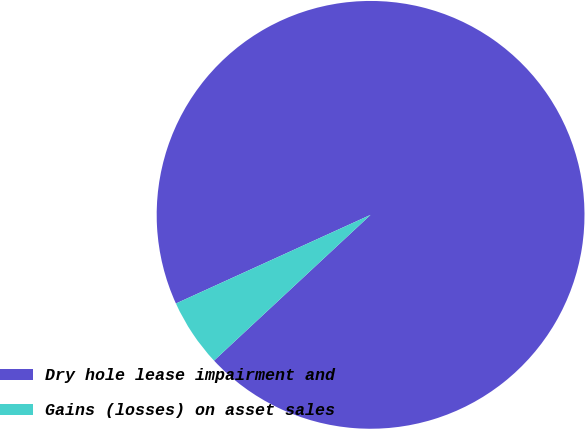Convert chart. <chart><loc_0><loc_0><loc_500><loc_500><pie_chart><fcel>Dry hole lease impairment and<fcel>Gains (losses) on asset sales<nl><fcel>94.87%<fcel>5.13%<nl></chart> 